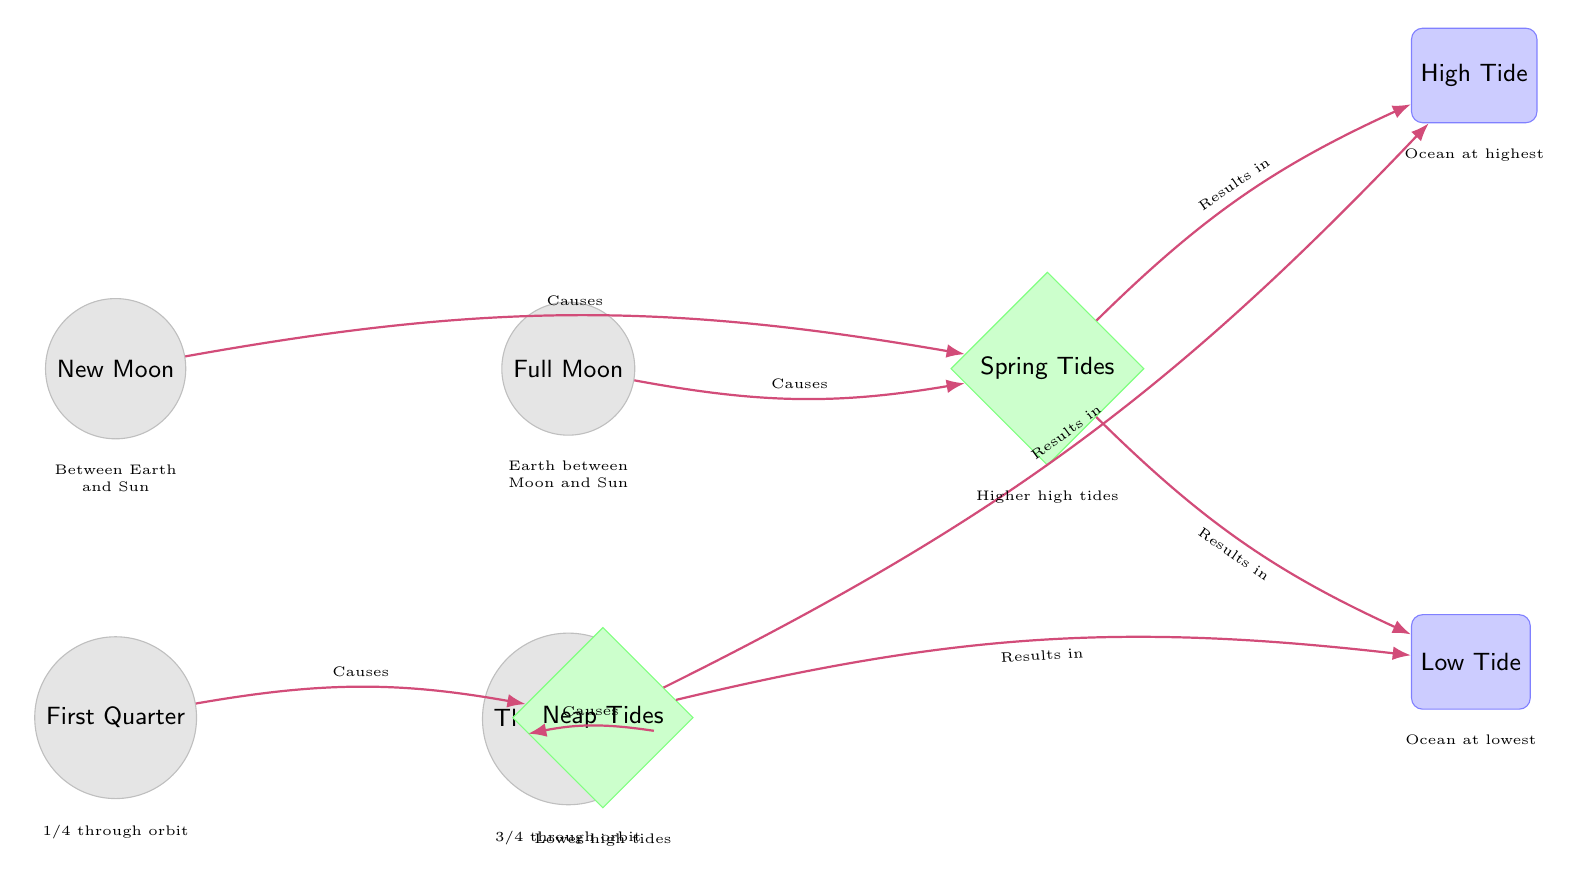What are the two main types of tides represented in the diagram? The diagram shows two types of tides: Spring Tides and Neap Tides, indicated by the nodes labeled "Spring Tides" and "Neap Tides."
Answer: Spring Tides, Neap Tides Which moon phase causes the Neap Tides? The diagram indicates that both the First Quarter and Third Quarter moon phases cause Neap Tides. These connections are indicated by arrows pointing to the Neap Tides node from both moon phases.
Answer: First Quarter, Third Quarter How many nodes are represented in the diagram? To find the number of nodes, count all the moon phase nodes (New Moon, Full Moon, First Quarter, Third Quarter) and all the tide effect nodes (Spring Tides, Neap Tides, High Tide, Low Tide). There are a total of 8 nodes.
Answer: 8 What results from Spring Tides according to the diagram? The diagram specifies that Spring Tides result in both High Tide and Low Tide, represented by arrows pointing from the Spring Tides node to both the High Tide and Low Tide nodes.
Answer: High Tide, Low Tide What is the position of the Full Moon in relation to New Moon? The diagram shows that the Full Moon is positioned to the right of the New Moon node, demonstrating their sequential relationship in the lunar cycle.
Answer: Right What is indicated as the highest ocean level in the diagram? The diagram specifically labels the node for the highest ocean level as "High Tide," which is linked to both Spring and Neap Tides.
Answer: High Tide How do Spring Tides compare to Neap Tides in terms of high tide height? The diagram illustrates that Spring Tides lead to Higher high tides while Neap Tides lead to Lower high tides, as indicated by the descriptions below the respective tide effect nodes.
Answer: Higher high tides, Lower high tides Which moon phase occurs between Earth and the Sun? According to the diagram, the New Moon phase occurs when the Moon is positioned between the Earth and the Sun, as indicated in the description below the New Moon node.
Answer: New Moon 